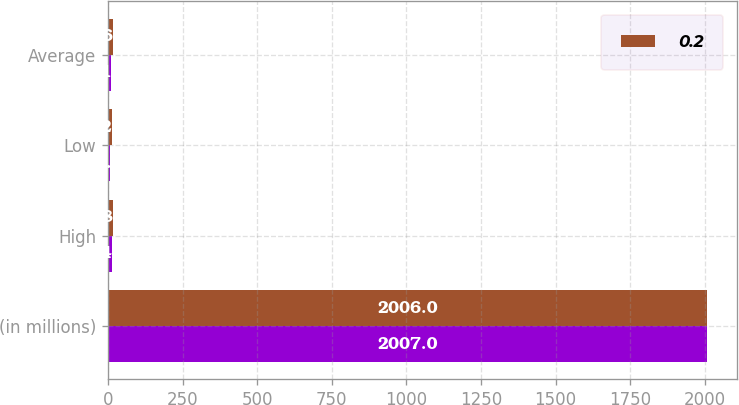Convert chart. <chart><loc_0><loc_0><loc_500><loc_500><stacked_bar_chart><ecel><fcel>(in millions)<fcel>High<fcel>Low<fcel>Average<nl><fcel>nan<fcel>2007<fcel>14.3<fcel>7.7<fcel>11<nl><fcel>0.2<fcel>2006<fcel>18<fcel>12.9<fcel>16.7<nl></chart> 